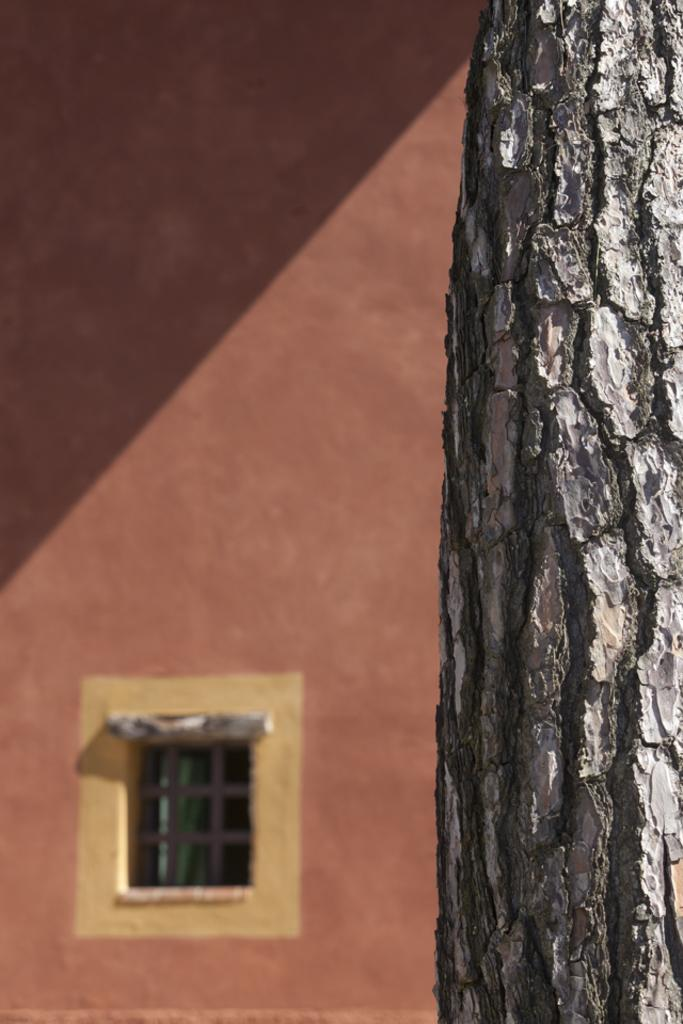What is the main object in the foreground of the image? There is a tree trunk in the image. What can be seen in the background of the image? There is a window and a wall in the background of the image. How many grapes are hanging from the tree trunk in the image? There are no grapes present in the image; it features a tree trunk without any fruit. 